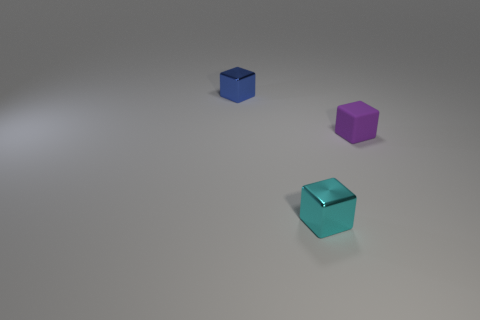Are there any tiny cyan objects that have the same material as the small blue object?
Offer a terse response. Yes. The tiny matte thing has what color?
Keep it short and to the point. Purple. What number of other objects are there of the same shape as the tiny blue metallic thing?
Your answer should be compact. 2. There is a thing that is both behind the cyan block and right of the small blue thing; what is its color?
Offer a very short reply. Purple. Are there any other things that are the same size as the rubber block?
Keep it short and to the point. Yes. What number of spheres are tiny red shiny objects or purple matte things?
Provide a short and direct response. 0. There is a metal block on the left side of the small metallic cube that is in front of the matte object right of the small blue thing; what is its color?
Ensure brevity in your answer.  Blue. Are the tiny purple block and the blue block made of the same material?
Provide a succinct answer. No. How many brown objects are large cubes or shiny blocks?
Offer a very short reply. 0. There is a tiny matte object; how many metal blocks are left of it?
Keep it short and to the point. 2. 